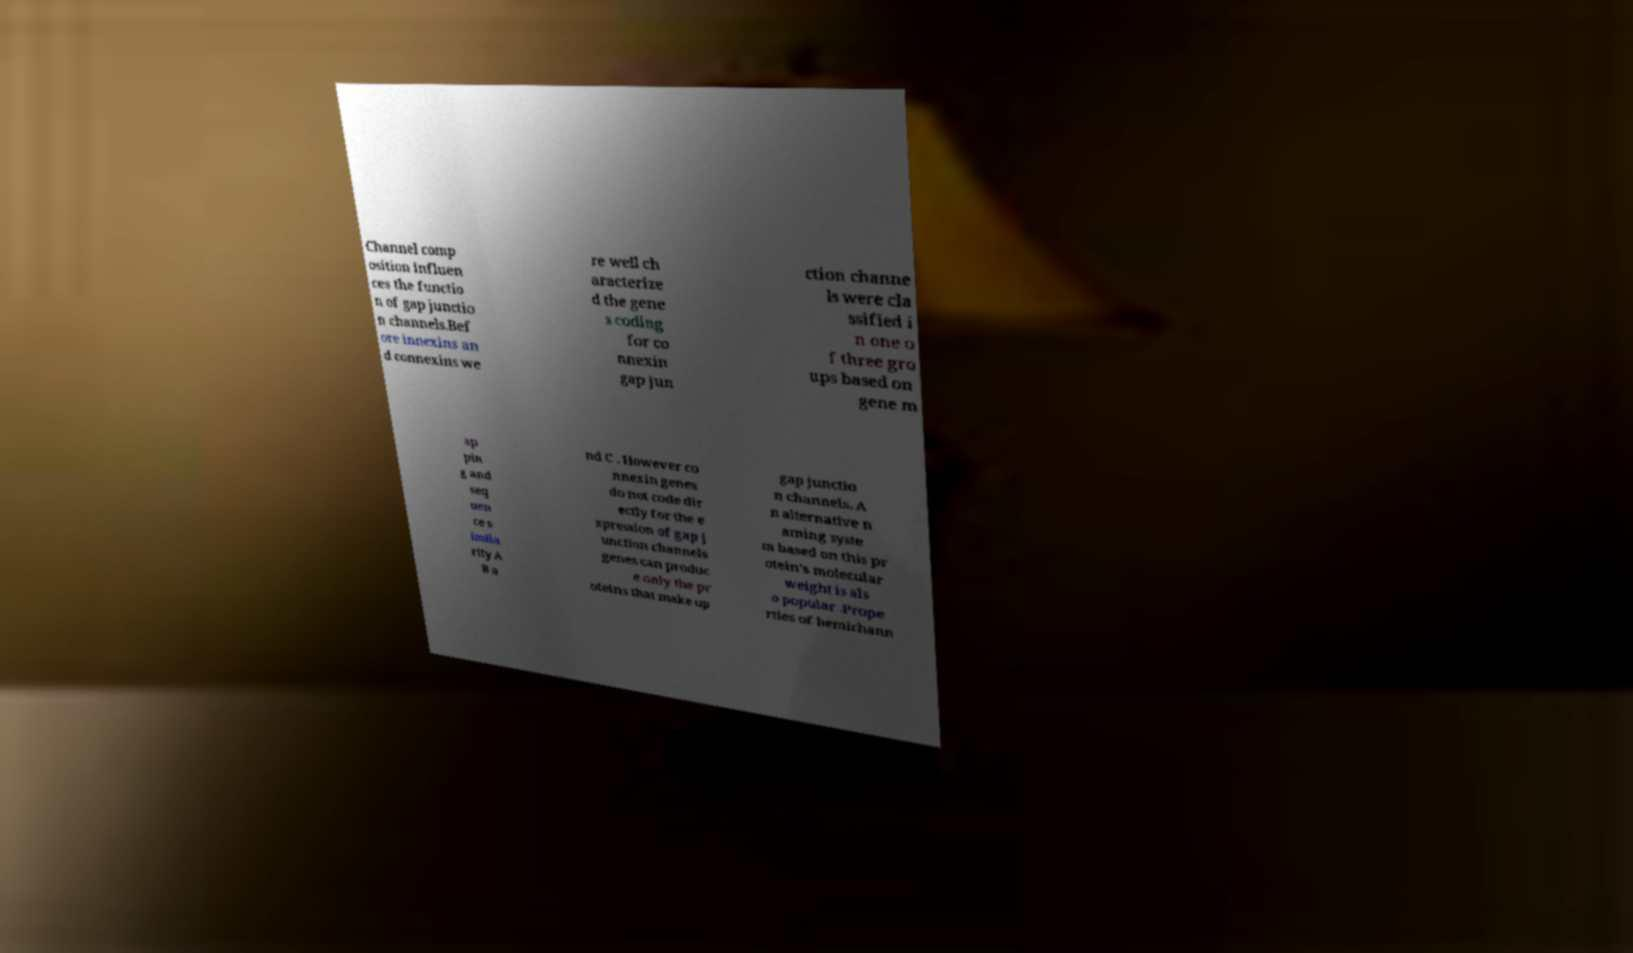Please identify and transcribe the text found in this image. Channel comp osition influen ces the functio n of gap junctio n channels.Bef ore innexins an d connexins we re well ch aracterize d the gene s coding for co nnexin gap jun ction channe ls were cla ssified i n one o f three gro ups based on gene m ap pin g and seq uen ce s imila rity A B a nd C . However co nnexin genes do not code dir ectly for the e xpression of gap j unction channels genes can produc e only the pr oteins that make up gap junctio n channels. A n alternative n aming syste m based on this pr otein's molecular weight is als o popular .Prope rties of hemichann 